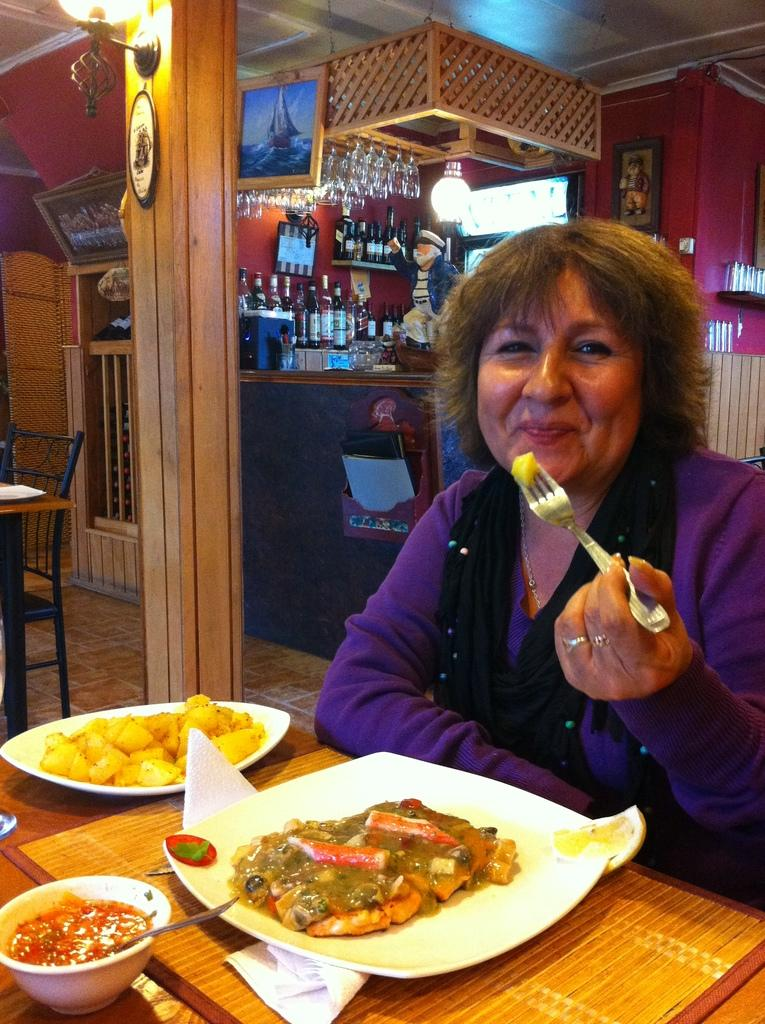What is the person in the image doing? The person is sitting in front of a table. What is on the table in the image? There is a plate with food and a bowl on the table. What can be seen in the background of the image? There is a wine shop and light visible in the background. How many feathers can be seen on the table in the image? There are no feathers present on the table in the image. What is the distance between the person and the wine shop in the image? The distance between the person and the wine shop cannot be determined from the image alone. 